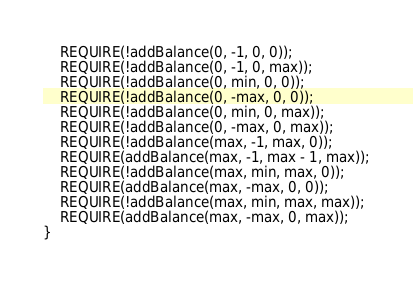<code> <loc_0><loc_0><loc_500><loc_500><_C++_>    REQUIRE(!addBalance(0, -1, 0, 0));
    REQUIRE(!addBalance(0, -1, 0, max));
    REQUIRE(!addBalance(0, min, 0, 0));
    REQUIRE(!addBalance(0, -max, 0, 0));
    REQUIRE(!addBalance(0, min, 0, max));
    REQUIRE(!addBalance(0, -max, 0, max));
    REQUIRE(!addBalance(max, -1, max, 0));
    REQUIRE(addBalance(max, -1, max - 1, max));
    REQUIRE(!addBalance(max, min, max, 0));
    REQUIRE(addBalance(max, -max, 0, 0));
    REQUIRE(!addBalance(max, min, max, max));
    REQUIRE(addBalance(max, -max, 0, max));
}
</code> 